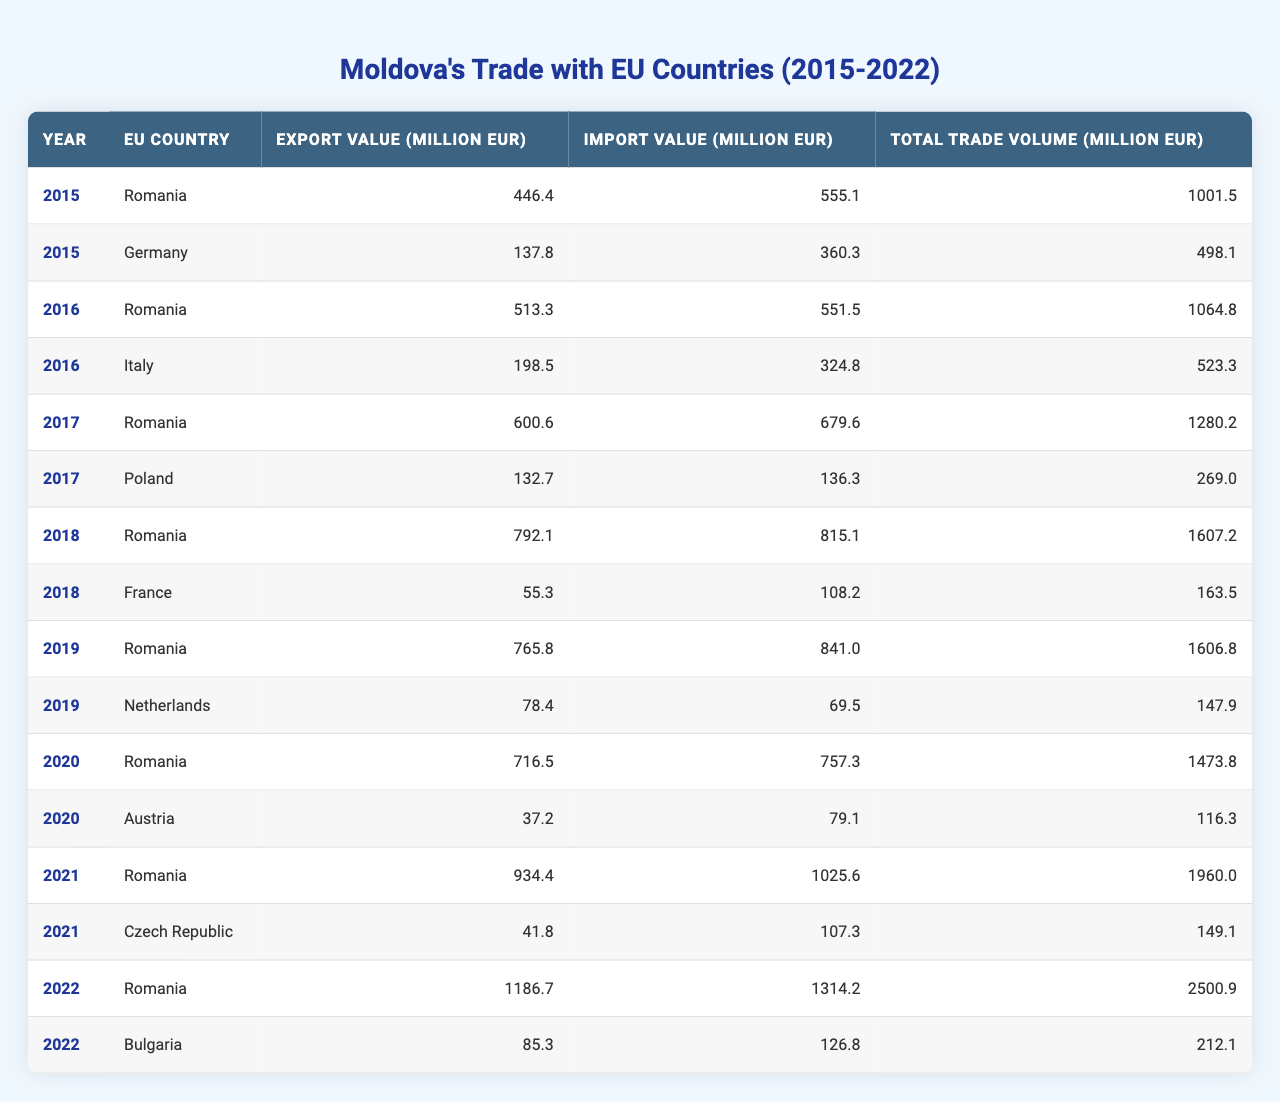What was Moldova's total trade volume with Romania in 2022? In 2022, the table shows that Moldova's total trade volume with Romania was 2500.9 million EUR.
Answer: 2500.9 million EUR Which EU country had the highest export value to Moldova in 2021? In 2021, the table shows that Romania had the highest export value to Moldova with 934.4 million EUR.
Answer: Romania What is the total import value from Italy in 2016? The table shows that Moldova's total import value from Italy in 2016 was 324.8 million EUR.
Answer: 324.8 million EUR What is the difference in total trade volume between 2019 and 2020 with Romania? In 2019, the total trade volume with Romania was 1606.8 million EUR, and in 2020 it was 1473.8 million EUR. The difference is 1606.8 - 1473.8 = 133 million EUR.
Answer: 133 million EUR Did Moldova's total trade volume with the Netherlands increase from 2019 to 2020? In 2019, the total trade volume with the Netherlands was 147.9 million EUR, and in 2020, there is no record of trade with the Netherlands, indicating a decrease.
Answer: No What is the average export value from all listed countries in 2015? Adding the export values from Romania (446.4), Germany (137.8), gives a sum of 584.2 million EUR. There are 2 countries, so the average export value is 584.2 / 2 = 292.1 million EUR.
Answer: 292.1 million EUR Which year showed the largest increase in trade volume for Romania compared to the previous year? Comparing the total trade volume values for Romania: 2015 (1001.5), 2016 (1064.8), 2017 (1280.2), 2018 (1607.2), 2019 (1606.8), 2020 (1473.8), 2021 (1960.0), 2022 (2500.9), the largest increase is from 2021 to 2022 which is 2500.9 - 1960.0 = 540.9 million EUR.
Answer: 540.9 million EUR Which EU country did Moldova import the least from in 2018? The table shows that in 2018, the import value from France was 108.2 million EUR, which is lower than the import values from other countries listed for that year.
Answer: France What is the total trade volume with Bulgaria in 2022 compared to Germany in 2015? The total trade volume with Bulgaria in 2022 is 212.1 million EUR, and with Germany in 2015, it was 498.1 million EUR. The volume with Bulgaria is less than that with Germany.
Answer: Less 